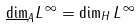<formula> <loc_0><loc_0><loc_500><loc_500>\underline { \dim } _ { A } L ^ { \, \infty } = \dim _ { H } L ^ { \, \infty }</formula> 